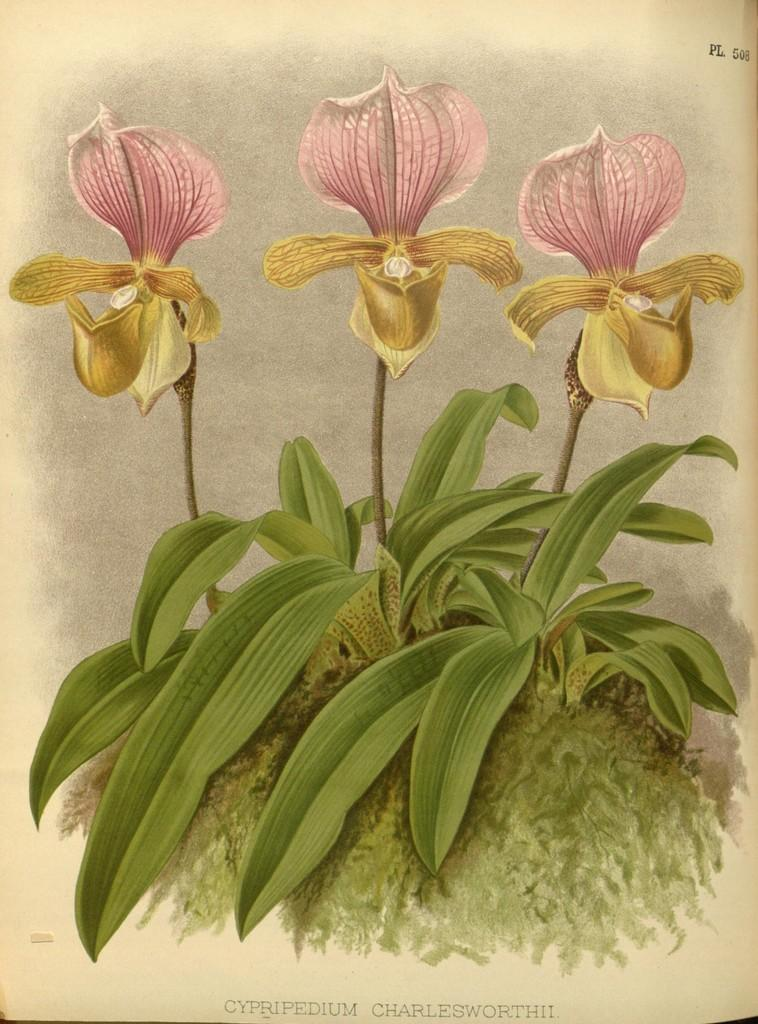What is the main subject of the image? There is a poster in the image. What is depicted on the poster? The poster contains plants and flowers. Is there any text present in the image? Yes, there is text at the bottom of the image. How does the anger in the image affect the expansion of the butter? There is no anger, expansion, or butter present in the image. The image only features a poster with plants and flowers, along with some text at the bottom. 